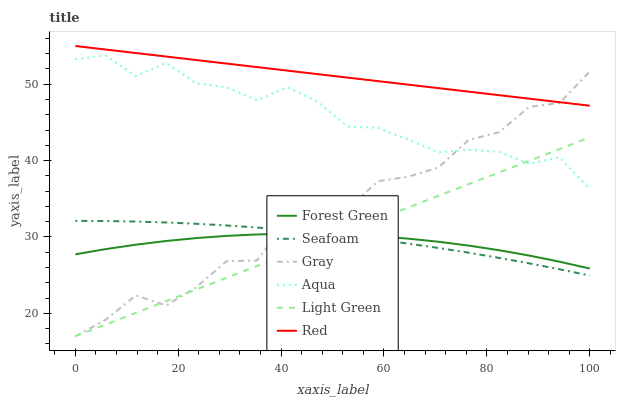Does Forest Green have the minimum area under the curve?
Answer yes or no. Yes. Does Red have the maximum area under the curve?
Answer yes or no. Yes. Does Aqua have the minimum area under the curve?
Answer yes or no. No. Does Aqua have the maximum area under the curve?
Answer yes or no. No. Is Red the smoothest?
Answer yes or no. Yes. Is Gray the roughest?
Answer yes or no. Yes. Is Aqua the smoothest?
Answer yes or no. No. Is Aqua the roughest?
Answer yes or no. No. Does Aqua have the lowest value?
Answer yes or no. No. Does Aqua have the highest value?
Answer yes or no. No. Is Seafoam less than Aqua?
Answer yes or no. Yes. Is Red greater than Forest Green?
Answer yes or no. Yes. Does Seafoam intersect Aqua?
Answer yes or no. No. 